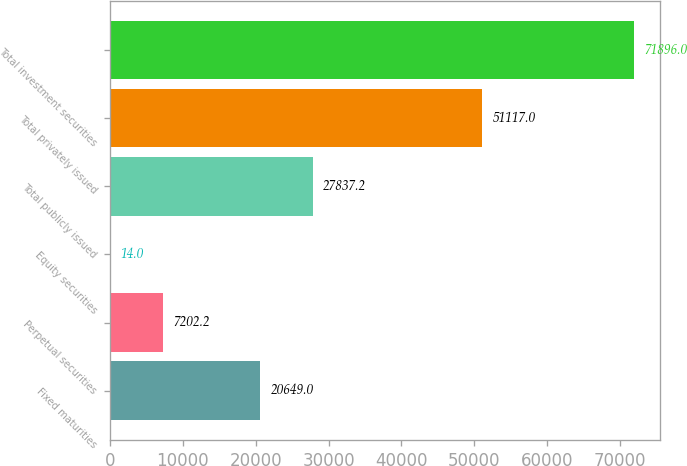Convert chart to OTSL. <chart><loc_0><loc_0><loc_500><loc_500><bar_chart><fcel>Fixed maturities<fcel>Perpetual securities<fcel>Equity securities<fcel>Total publicly issued<fcel>Total privately issued<fcel>Total investment securities<nl><fcel>20649<fcel>7202.2<fcel>14<fcel>27837.2<fcel>51117<fcel>71896<nl></chart> 